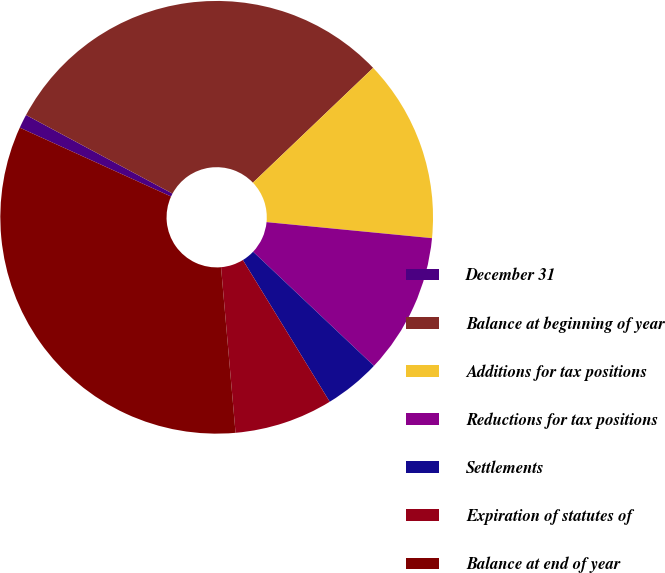Convert chart to OTSL. <chart><loc_0><loc_0><loc_500><loc_500><pie_chart><fcel>December 31<fcel>Balance at beginning of year<fcel>Additions for tax positions<fcel>Reductions for tax positions<fcel>Settlements<fcel>Expiration of statutes of<fcel>Balance at end of year<nl><fcel>1.04%<fcel>30.03%<fcel>13.67%<fcel>10.51%<fcel>4.2%<fcel>7.36%<fcel>33.19%<nl></chart> 